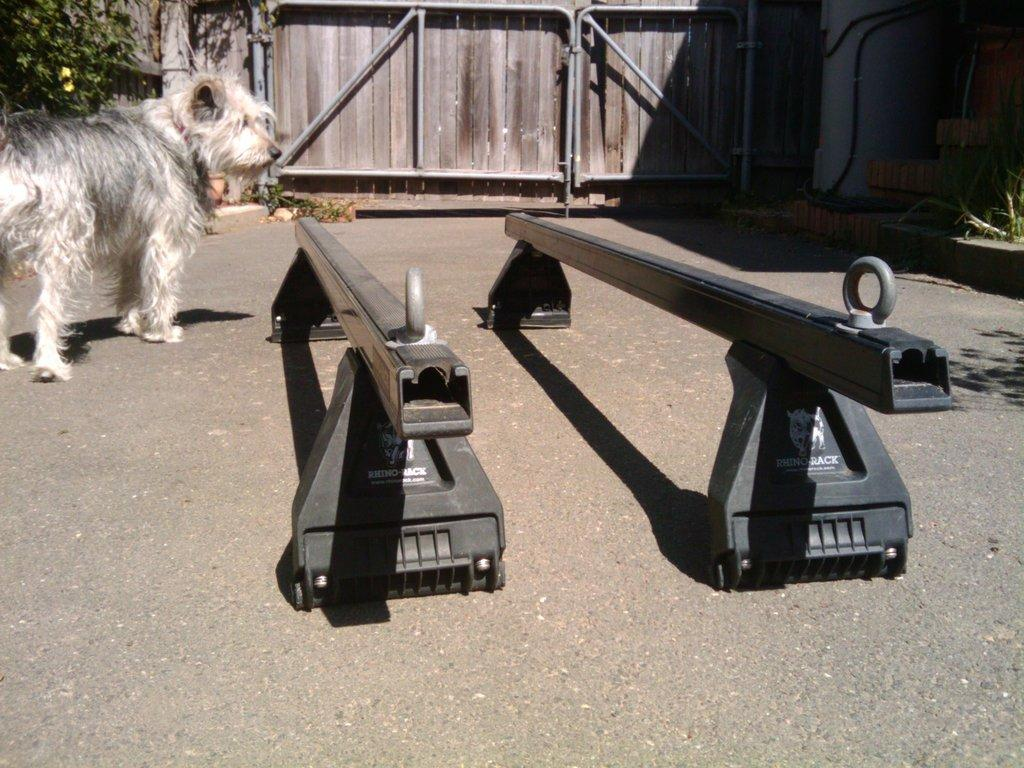What animal is located on the left side of the image? There is a dog on the left side of the image. What structure can be seen at the top of the image? There is a gate at the top of the image. What objects are in the middle of the image? There are two iron stands in the middle of the image. Who is the manager of the metal plough in the image? There is no mention of a manager or a plough in the image; it features a dog, a gate, and two iron stands. 